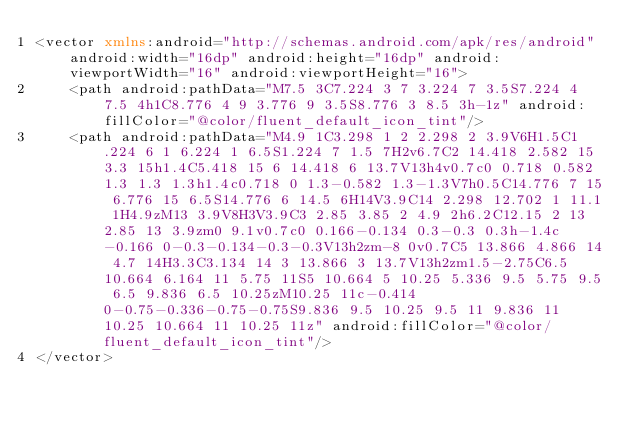<code> <loc_0><loc_0><loc_500><loc_500><_XML_><vector xmlns:android="http://schemas.android.com/apk/res/android" android:width="16dp" android:height="16dp" android:viewportWidth="16" android:viewportHeight="16">
    <path android:pathData="M7.5 3C7.224 3 7 3.224 7 3.5S7.224 4 7.5 4h1C8.776 4 9 3.776 9 3.5S8.776 3 8.5 3h-1z" android:fillColor="@color/fluent_default_icon_tint"/>
    <path android:pathData="M4.9 1C3.298 1 2 2.298 2 3.9V6H1.5C1.224 6 1 6.224 1 6.5S1.224 7 1.5 7H2v6.7C2 14.418 2.582 15 3.3 15h1.4C5.418 15 6 14.418 6 13.7V13h4v0.7c0 0.718 0.582 1.3 1.3 1.3h1.4c0.718 0 1.3-0.582 1.3-1.3V7h0.5C14.776 7 15 6.776 15 6.5S14.776 6 14.5 6H14V3.9C14 2.298 12.702 1 11.1 1H4.9zM13 3.9V8H3V3.9C3 2.85 3.85 2 4.9 2h6.2C12.15 2 13 2.85 13 3.9zm0 9.1v0.7c0 0.166-0.134 0.3-0.3 0.3h-1.4c-0.166 0-0.3-0.134-0.3-0.3V13h2zm-8 0v0.7C5 13.866 4.866 14 4.7 14H3.3C3.134 14 3 13.866 3 13.7V13h2zm1.5-2.75C6.5 10.664 6.164 11 5.75 11S5 10.664 5 10.25 5.336 9.5 5.75 9.5 6.5 9.836 6.5 10.25zM10.25 11c-0.414 0-0.75-0.336-0.75-0.75S9.836 9.5 10.25 9.5 11 9.836 11 10.25 10.664 11 10.25 11z" android:fillColor="@color/fluent_default_icon_tint"/>
</vector>
</code> 